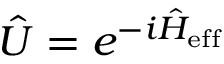Convert formula to latex. <formula><loc_0><loc_0><loc_500><loc_500>\hat { U } = e ^ { - i \hat { H } _ { e f f } }</formula> 